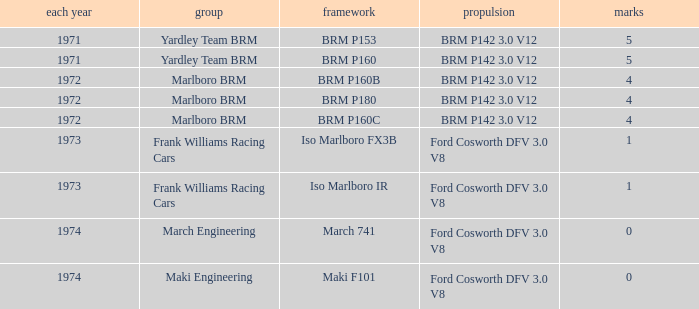Give me the full table as a dictionary. {'header': ['each year', 'group', 'framework', 'propulsion', 'marks'], 'rows': [['1971', 'Yardley Team BRM', 'BRM P153', 'BRM P142 3.0 V12', '5'], ['1971', 'Yardley Team BRM', 'BRM P160', 'BRM P142 3.0 V12', '5'], ['1972', 'Marlboro BRM', 'BRM P160B', 'BRM P142 3.0 V12', '4'], ['1972', 'Marlboro BRM', 'BRM P180', 'BRM P142 3.0 V12', '4'], ['1972', 'Marlboro BRM', 'BRM P160C', 'BRM P142 3.0 V12', '4'], ['1973', 'Frank Williams Racing Cars', 'Iso Marlboro FX3B', 'Ford Cosworth DFV 3.0 V8', '1'], ['1973', 'Frank Williams Racing Cars', 'Iso Marlboro IR', 'Ford Cosworth DFV 3.0 V8', '1'], ['1974', 'March Engineering', 'March 741', 'Ford Cosworth DFV 3.0 V8', '0'], ['1974', 'Maki Engineering', 'Maki F101', 'Ford Cosworth DFV 3.0 V8', '0']]} What are the highest points for the team of marlboro brm with brm p180 as the chassis? 4.0. 